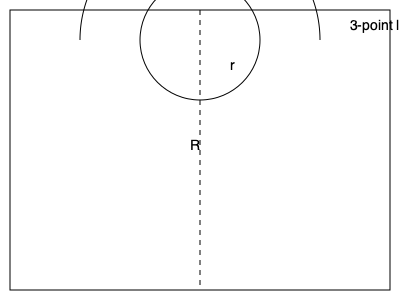In a regulation basketball court, the three-point line forms an arc with a radius of 23.75 feet from the center of the basket. If the free-throw line is 15 feet from the backboard and the backboard is 4 feet from the baseline, what is the distance between the top of the three-point arc and the free-throw line? Let's approach this step-by-step:

1) First, we need to identify the important measurements:
   - Three-point line radius (R) = 23.75 feet
   - Free-throw line distance from backboard = 15 feet
   - Backboard distance from baseline = 4 feet

2) The distance we're looking for is the difference between the radius of the three-point arc and the distance from the basket to the free-throw line.

3) To find the distance from the basket to the free-throw line:
   - Total distance = Free-throw line distance + Backboard distance
   - Distance = 15 + 4 = 19 feet

4) Now we can calculate the difference:
   Distance = Three-point line radius - Distance to free-throw line
   $$D = R - 19$$
   $$D = 23.75 - 19$$
   $$D = 4.75\text{ feet}$$

Therefore, the distance between the top of the three-point arc and the free-throw line is 4.75 feet.
Answer: 4.75 feet 